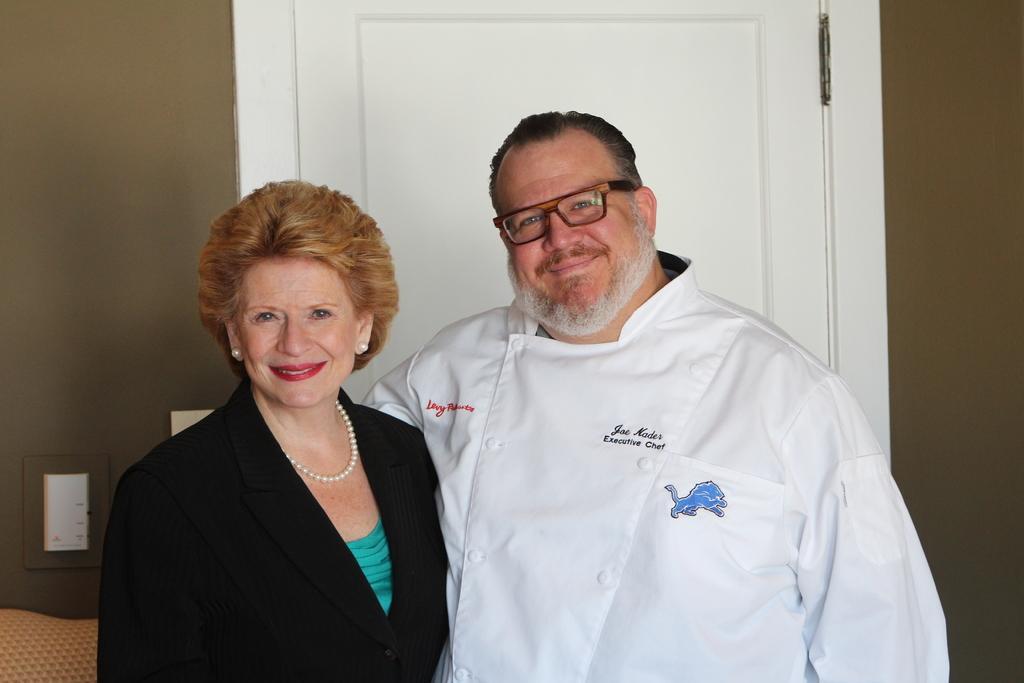Describe this image in one or two sentences. In this image there is one man and woman, and in the background there is door, wall and some objects. 